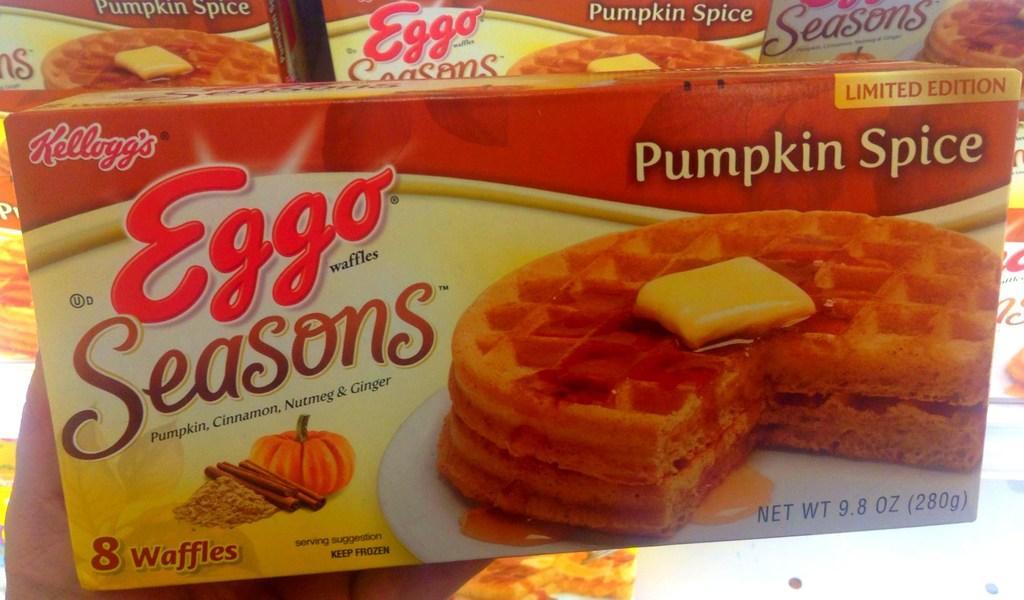Can you describe this image briefly? In this image I can see a human hand holding a box which is red, yellow and white in color. In the background I can see few other boxes. 